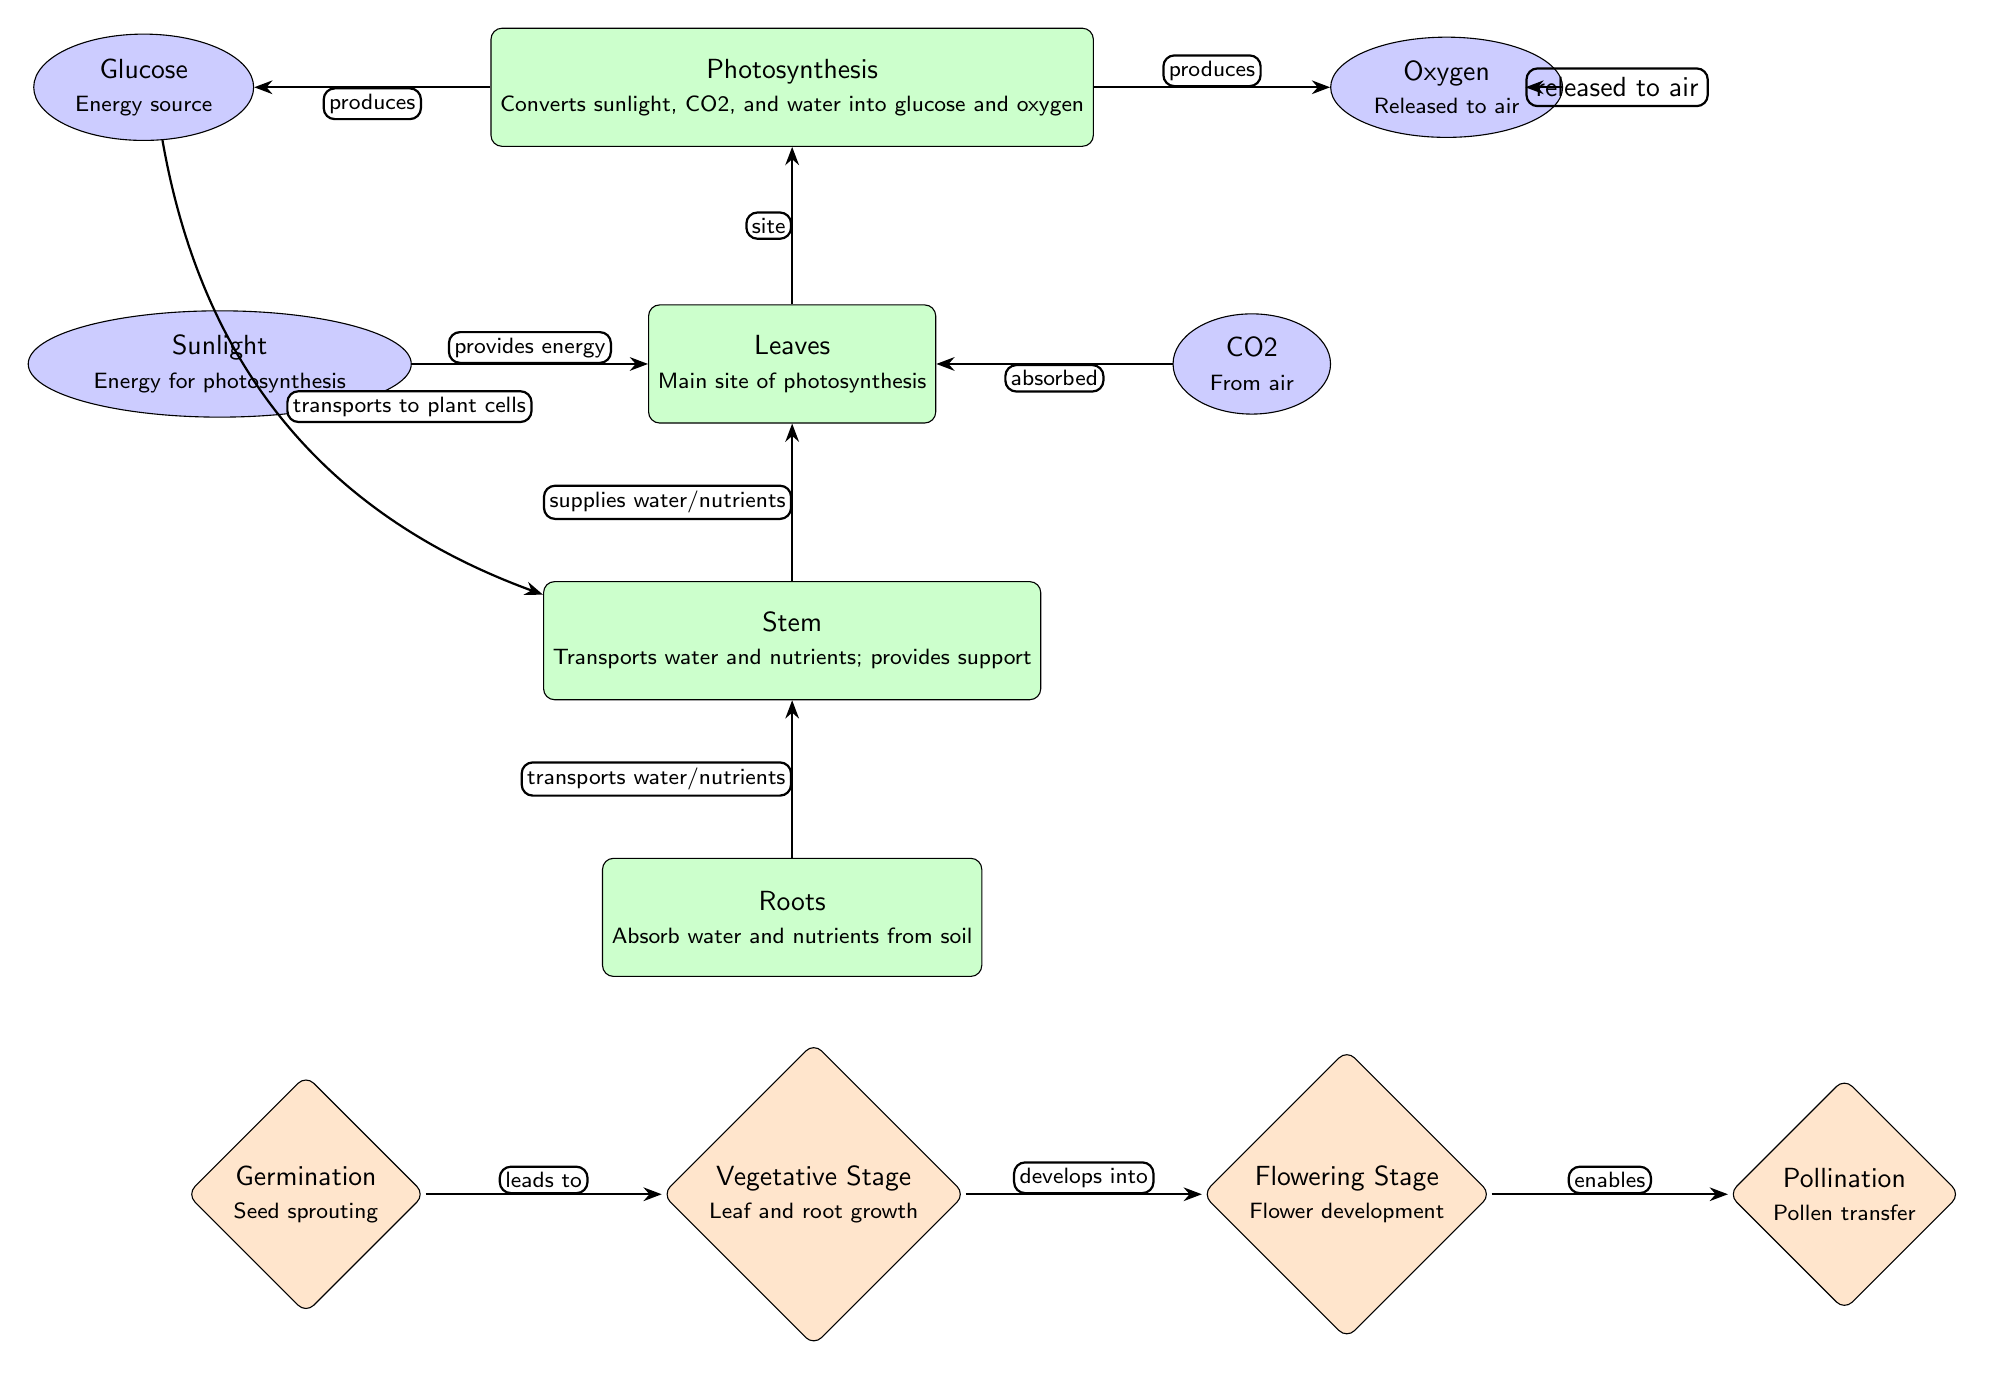How many growth stages are shown in the diagram? The diagram includes four distinct growth stages: Germination, Vegetative Stage, Flowering Stage, and Pollination. Therefore, counting these stages gives a total of 4.
Answer: 4 What is the function of the leaves in the plant? According to the diagram, the function of the leaves is described as the "Main site of photosynthesis," where the process primarily occurs.
Answer: Main site of photosynthesis What do roots absorb from the soil? The roots' function, as stated in the diagram, is to "Absorb water and nutrients from soil," which specifies what they take in from the environment.
Answer: Water and nutrients What does photosynthesis produce? The diagram indicates that the photosynthesis process produces two products: Glucose and Oxygen. Therefore, both outputs are the result of this process.
Answer: Glucose and Oxygen What is the relationship between the flowering stage and pollination? The diagram depicts an arrow labeled "enables" pointing from the Flowering Stage to Pollination, indicating that the flowering stage is a necessary precursor or facilitator for the pollination process to occur.
Answer: Enables How does sunlight contribute to photosynthesis? The diagram illustrates an arrow from Sunlight to Leaves, with a label that states "provides energy." This shows that sunlight's role is to supply the energy required for the photosynthesis process in the leaves.
Answer: Provides energy What does the stem do? The diagram explicitly states that the stem functions to "Transport water and nutrients; provides support," which outlines its key roles within the plant's anatomy.
Answer: Transport water and nutrients; provides support Identify the process that happens above the leaves in the diagram. The diagram positions the photosynthesis node directly above the leaves, indicating that this process occurs at that level and is central to the function of leaves in the plant.
Answer: Photosynthesis What happens during germination according to the diagram? The growth stage labeled "Germination" describes the process as "Seed sprouting," which succinctly defines what occurs at this initial stage of growth for the plant.
Answer: Seed sprouting 